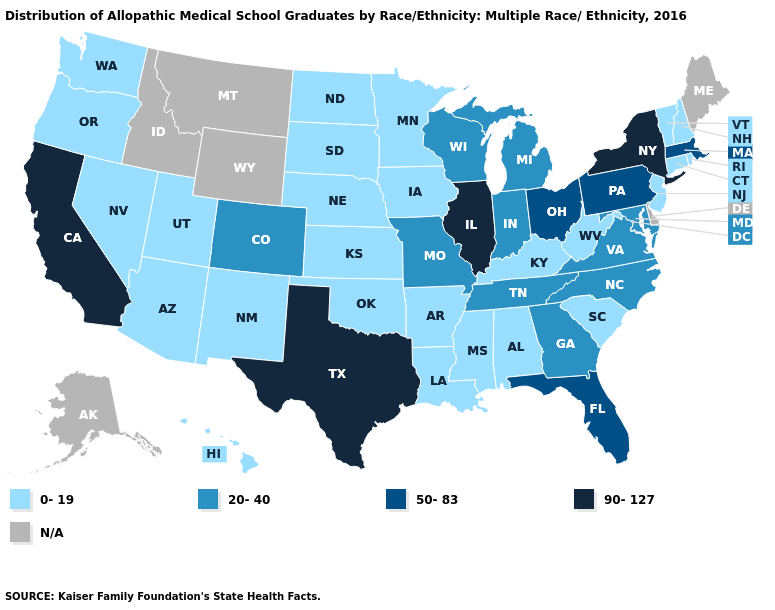Does the map have missing data?
Give a very brief answer. Yes. Name the states that have a value in the range 90-127?
Write a very short answer. California, Illinois, New York, Texas. Does California have the highest value in the USA?
Write a very short answer. Yes. Name the states that have a value in the range 20-40?
Give a very brief answer. Colorado, Georgia, Indiana, Maryland, Michigan, Missouri, North Carolina, Tennessee, Virginia, Wisconsin. Which states have the highest value in the USA?
Short answer required. California, Illinois, New York, Texas. Among the states that border New Hampshire , which have the lowest value?
Write a very short answer. Vermont. What is the lowest value in the USA?
Give a very brief answer. 0-19. Does the first symbol in the legend represent the smallest category?
Keep it brief. Yes. Name the states that have a value in the range 0-19?
Write a very short answer. Alabama, Arizona, Arkansas, Connecticut, Hawaii, Iowa, Kansas, Kentucky, Louisiana, Minnesota, Mississippi, Nebraska, Nevada, New Hampshire, New Jersey, New Mexico, North Dakota, Oklahoma, Oregon, Rhode Island, South Carolina, South Dakota, Utah, Vermont, Washington, West Virginia. Does New Hampshire have the lowest value in the Northeast?
Quick response, please. Yes. Name the states that have a value in the range 20-40?
Write a very short answer. Colorado, Georgia, Indiana, Maryland, Michigan, Missouri, North Carolina, Tennessee, Virginia, Wisconsin. What is the highest value in the Northeast ?
Concise answer only. 90-127. Name the states that have a value in the range N/A?
Quick response, please. Alaska, Delaware, Idaho, Maine, Montana, Wyoming. Which states hav the highest value in the MidWest?
Answer briefly. Illinois. 